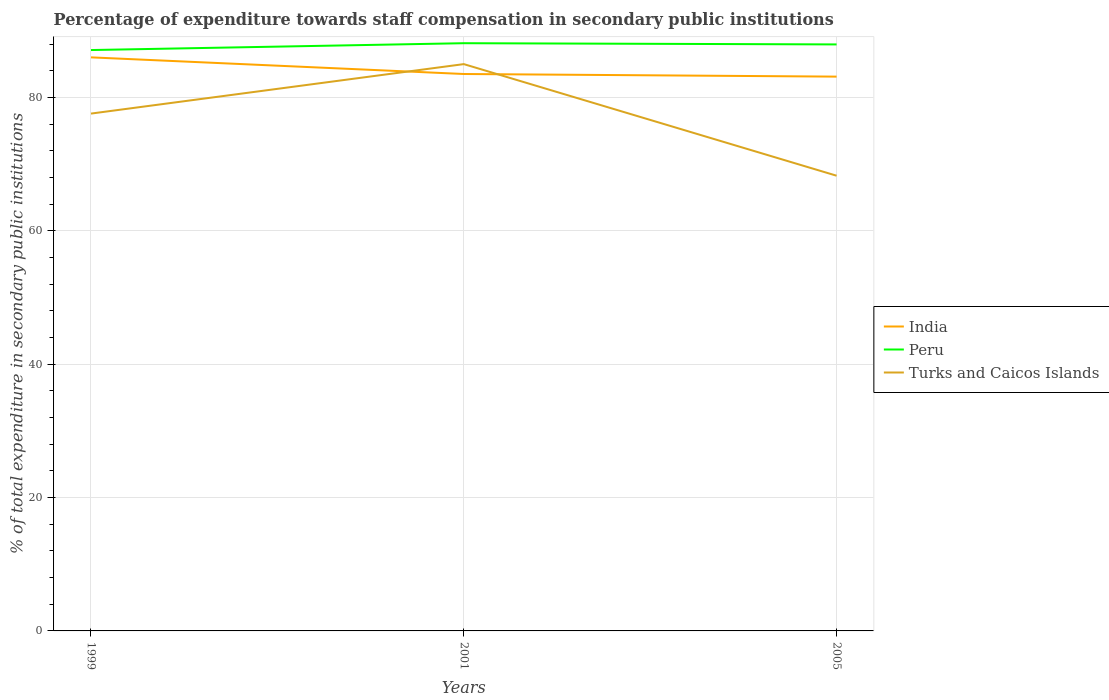How many different coloured lines are there?
Provide a short and direct response. 3. Across all years, what is the maximum percentage of expenditure towards staff compensation in Turks and Caicos Islands?
Ensure brevity in your answer.  68.27. In which year was the percentage of expenditure towards staff compensation in India maximum?
Make the answer very short. 2005. What is the total percentage of expenditure towards staff compensation in Turks and Caicos Islands in the graph?
Your answer should be very brief. -7.42. What is the difference between the highest and the second highest percentage of expenditure towards staff compensation in Peru?
Make the answer very short. 1.03. What is the difference between the highest and the lowest percentage of expenditure towards staff compensation in Turks and Caicos Islands?
Provide a short and direct response. 2. What is the difference between two consecutive major ticks on the Y-axis?
Provide a short and direct response. 20. Does the graph contain any zero values?
Offer a terse response. No. How are the legend labels stacked?
Provide a succinct answer. Vertical. What is the title of the graph?
Your answer should be compact. Percentage of expenditure towards staff compensation in secondary public institutions. What is the label or title of the X-axis?
Make the answer very short. Years. What is the label or title of the Y-axis?
Provide a succinct answer. % of total expenditure in secondary public institutions. What is the % of total expenditure in secondary public institutions in India in 1999?
Your response must be concise. 86.02. What is the % of total expenditure in secondary public institutions in Peru in 1999?
Give a very brief answer. 87.12. What is the % of total expenditure in secondary public institutions of Turks and Caicos Islands in 1999?
Your answer should be very brief. 77.59. What is the % of total expenditure in secondary public institutions in India in 2001?
Offer a terse response. 83.52. What is the % of total expenditure in secondary public institutions of Peru in 2001?
Make the answer very short. 88.14. What is the % of total expenditure in secondary public institutions in Turks and Caicos Islands in 2001?
Your answer should be very brief. 85.01. What is the % of total expenditure in secondary public institutions of India in 2005?
Your answer should be very brief. 83.13. What is the % of total expenditure in secondary public institutions of Peru in 2005?
Provide a succinct answer. 87.96. What is the % of total expenditure in secondary public institutions in Turks and Caicos Islands in 2005?
Make the answer very short. 68.27. Across all years, what is the maximum % of total expenditure in secondary public institutions in India?
Your answer should be compact. 86.02. Across all years, what is the maximum % of total expenditure in secondary public institutions in Peru?
Your answer should be compact. 88.14. Across all years, what is the maximum % of total expenditure in secondary public institutions of Turks and Caicos Islands?
Give a very brief answer. 85.01. Across all years, what is the minimum % of total expenditure in secondary public institutions in India?
Provide a short and direct response. 83.13. Across all years, what is the minimum % of total expenditure in secondary public institutions of Peru?
Your answer should be very brief. 87.12. Across all years, what is the minimum % of total expenditure in secondary public institutions in Turks and Caicos Islands?
Offer a very short reply. 68.27. What is the total % of total expenditure in secondary public institutions in India in the graph?
Your answer should be very brief. 252.68. What is the total % of total expenditure in secondary public institutions in Peru in the graph?
Give a very brief answer. 263.22. What is the total % of total expenditure in secondary public institutions of Turks and Caicos Islands in the graph?
Your answer should be very brief. 230.87. What is the difference between the % of total expenditure in secondary public institutions in India in 1999 and that in 2001?
Provide a short and direct response. 2.5. What is the difference between the % of total expenditure in secondary public institutions of Peru in 1999 and that in 2001?
Offer a terse response. -1.03. What is the difference between the % of total expenditure in secondary public institutions in Turks and Caicos Islands in 1999 and that in 2001?
Provide a succinct answer. -7.42. What is the difference between the % of total expenditure in secondary public institutions of India in 1999 and that in 2005?
Your answer should be compact. 2.89. What is the difference between the % of total expenditure in secondary public institutions in Peru in 1999 and that in 2005?
Your response must be concise. -0.84. What is the difference between the % of total expenditure in secondary public institutions of Turks and Caicos Islands in 1999 and that in 2005?
Offer a terse response. 9.32. What is the difference between the % of total expenditure in secondary public institutions of India in 2001 and that in 2005?
Make the answer very short. 0.39. What is the difference between the % of total expenditure in secondary public institutions of Peru in 2001 and that in 2005?
Provide a succinct answer. 0.18. What is the difference between the % of total expenditure in secondary public institutions in Turks and Caicos Islands in 2001 and that in 2005?
Your answer should be very brief. 16.74. What is the difference between the % of total expenditure in secondary public institutions in India in 1999 and the % of total expenditure in secondary public institutions in Peru in 2001?
Ensure brevity in your answer.  -2.12. What is the difference between the % of total expenditure in secondary public institutions of India in 1999 and the % of total expenditure in secondary public institutions of Turks and Caicos Islands in 2001?
Provide a succinct answer. 1.01. What is the difference between the % of total expenditure in secondary public institutions of Peru in 1999 and the % of total expenditure in secondary public institutions of Turks and Caicos Islands in 2001?
Your answer should be compact. 2.11. What is the difference between the % of total expenditure in secondary public institutions in India in 1999 and the % of total expenditure in secondary public institutions in Peru in 2005?
Keep it short and to the point. -1.94. What is the difference between the % of total expenditure in secondary public institutions of India in 1999 and the % of total expenditure in secondary public institutions of Turks and Caicos Islands in 2005?
Your answer should be compact. 17.75. What is the difference between the % of total expenditure in secondary public institutions in Peru in 1999 and the % of total expenditure in secondary public institutions in Turks and Caicos Islands in 2005?
Offer a terse response. 18.85. What is the difference between the % of total expenditure in secondary public institutions of India in 2001 and the % of total expenditure in secondary public institutions of Peru in 2005?
Offer a terse response. -4.44. What is the difference between the % of total expenditure in secondary public institutions in India in 2001 and the % of total expenditure in secondary public institutions in Turks and Caicos Islands in 2005?
Make the answer very short. 15.25. What is the difference between the % of total expenditure in secondary public institutions of Peru in 2001 and the % of total expenditure in secondary public institutions of Turks and Caicos Islands in 2005?
Your answer should be very brief. 19.87. What is the average % of total expenditure in secondary public institutions in India per year?
Keep it short and to the point. 84.23. What is the average % of total expenditure in secondary public institutions in Peru per year?
Keep it short and to the point. 87.74. What is the average % of total expenditure in secondary public institutions of Turks and Caicos Islands per year?
Your answer should be compact. 76.96. In the year 1999, what is the difference between the % of total expenditure in secondary public institutions of India and % of total expenditure in secondary public institutions of Peru?
Give a very brief answer. -1.1. In the year 1999, what is the difference between the % of total expenditure in secondary public institutions of India and % of total expenditure in secondary public institutions of Turks and Caicos Islands?
Your response must be concise. 8.43. In the year 1999, what is the difference between the % of total expenditure in secondary public institutions in Peru and % of total expenditure in secondary public institutions in Turks and Caicos Islands?
Provide a short and direct response. 9.53. In the year 2001, what is the difference between the % of total expenditure in secondary public institutions of India and % of total expenditure in secondary public institutions of Peru?
Your answer should be very brief. -4.62. In the year 2001, what is the difference between the % of total expenditure in secondary public institutions in India and % of total expenditure in secondary public institutions in Turks and Caicos Islands?
Keep it short and to the point. -1.48. In the year 2001, what is the difference between the % of total expenditure in secondary public institutions in Peru and % of total expenditure in secondary public institutions in Turks and Caicos Islands?
Give a very brief answer. 3.14. In the year 2005, what is the difference between the % of total expenditure in secondary public institutions of India and % of total expenditure in secondary public institutions of Peru?
Keep it short and to the point. -4.83. In the year 2005, what is the difference between the % of total expenditure in secondary public institutions of India and % of total expenditure in secondary public institutions of Turks and Caicos Islands?
Keep it short and to the point. 14.86. In the year 2005, what is the difference between the % of total expenditure in secondary public institutions in Peru and % of total expenditure in secondary public institutions in Turks and Caicos Islands?
Your response must be concise. 19.69. What is the ratio of the % of total expenditure in secondary public institutions of India in 1999 to that in 2001?
Offer a terse response. 1.03. What is the ratio of the % of total expenditure in secondary public institutions of Peru in 1999 to that in 2001?
Your answer should be compact. 0.99. What is the ratio of the % of total expenditure in secondary public institutions in Turks and Caicos Islands in 1999 to that in 2001?
Keep it short and to the point. 0.91. What is the ratio of the % of total expenditure in secondary public institutions in India in 1999 to that in 2005?
Keep it short and to the point. 1.03. What is the ratio of the % of total expenditure in secondary public institutions of Peru in 1999 to that in 2005?
Give a very brief answer. 0.99. What is the ratio of the % of total expenditure in secondary public institutions in Turks and Caicos Islands in 1999 to that in 2005?
Provide a short and direct response. 1.14. What is the ratio of the % of total expenditure in secondary public institutions in India in 2001 to that in 2005?
Your answer should be compact. 1. What is the ratio of the % of total expenditure in secondary public institutions in Turks and Caicos Islands in 2001 to that in 2005?
Your answer should be compact. 1.25. What is the difference between the highest and the second highest % of total expenditure in secondary public institutions in India?
Give a very brief answer. 2.5. What is the difference between the highest and the second highest % of total expenditure in secondary public institutions in Peru?
Offer a very short reply. 0.18. What is the difference between the highest and the second highest % of total expenditure in secondary public institutions in Turks and Caicos Islands?
Keep it short and to the point. 7.42. What is the difference between the highest and the lowest % of total expenditure in secondary public institutions of India?
Give a very brief answer. 2.89. What is the difference between the highest and the lowest % of total expenditure in secondary public institutions in Peru?
Your response must be concise. 1.03. What is the difference between the highest and the lowest % of total expenditure in secondary public institutions of Turks and Caicos Islands?
Provide a succinct answer. 16.74. 